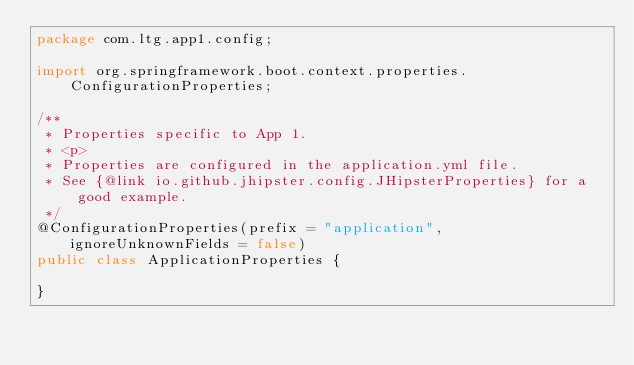<code> <loc_0><loc_0><loc_500><loc_500><_Java_>package com.ltg.app1.config;

import org.springframework.boot.context.properties.ConfigurationProperties;

/**
 * Properties specific to App 1.
 * <p>
 * Properties are configured in the application.yml file.
 * See {@link io.github.jhipster.config.JHipsterProperties} for a good example.
 */
@ConfigurationProperties(prefix = "application", ignoreUnknownFields = false)
public class ApplicationProperties {

}
</code> 